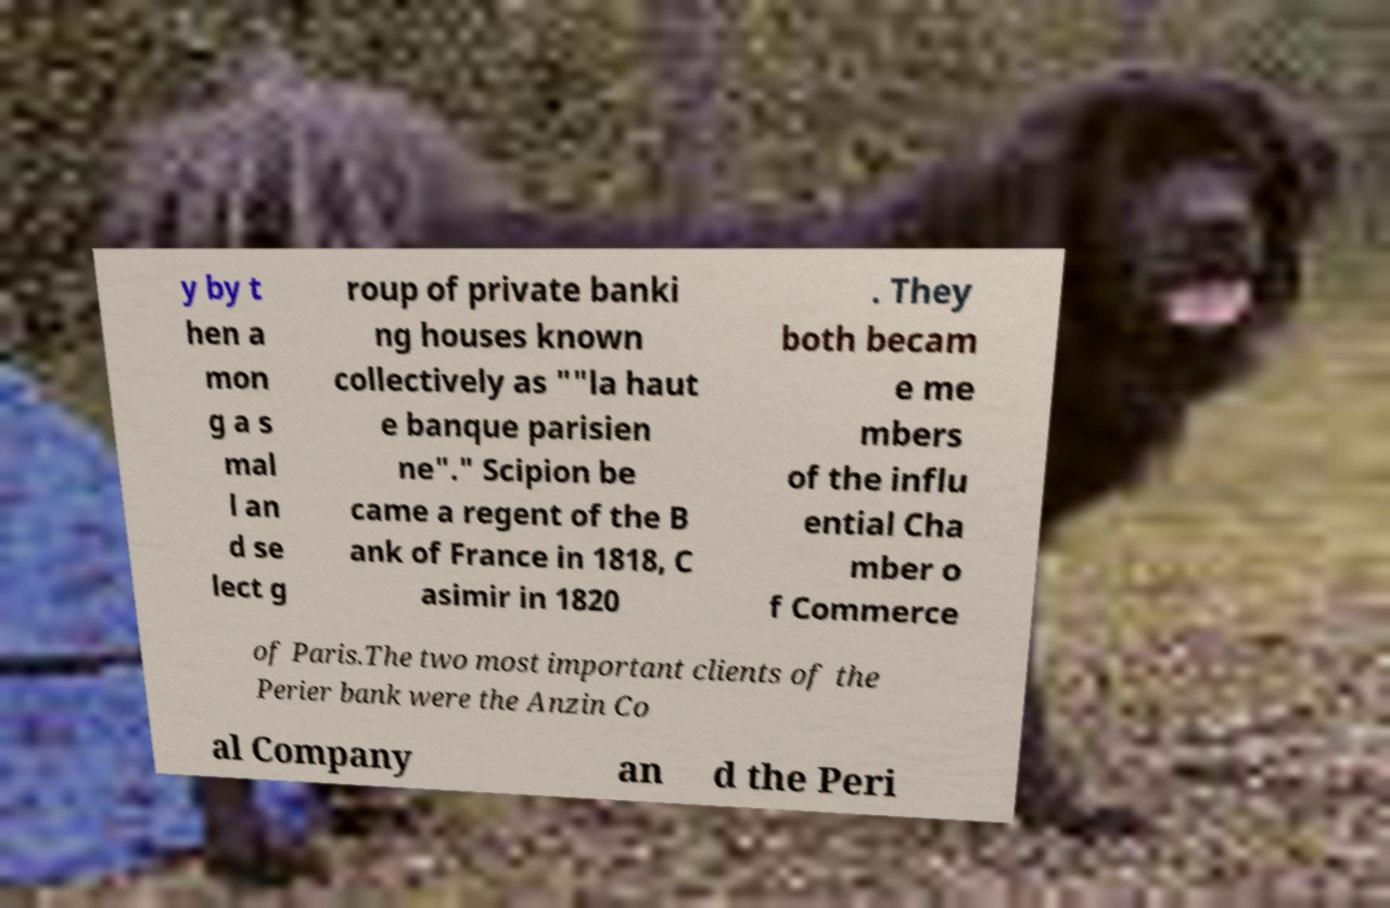There's text embedded in this image that I need extracted. Can you transcribe it verbatim? y by t hen a mon g a s mal l an d se lect g roup of private banki ng houses known collectively as ""la haut e banque parisien ne"." Scipion be came a regent of the B ank of France in 1818, C asimir in 1820 . They both becam e me mbers of the influ ential Cha mber o f Commerce of Paris.The two most important clients of the Perier bank were the Anzin Co al Company an d the Peri 